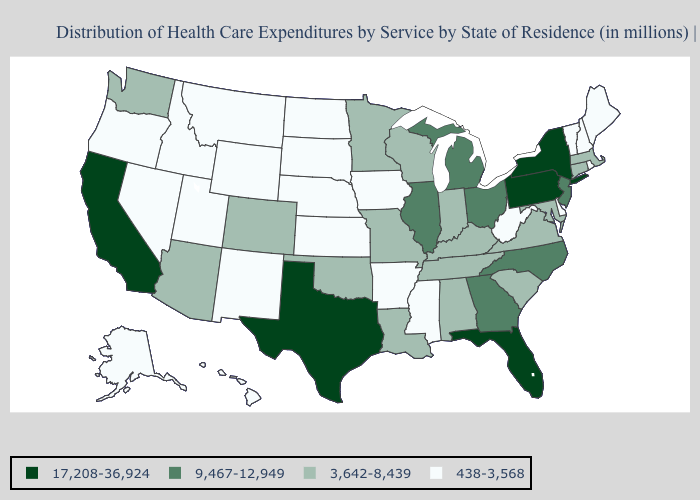Does the map have missing data?
Give a very brief answer. No. Does Louisiana have the lowest value in the USA?
Concise answer only. No. Name the states that have a value in the range 438-3,568?
Give a very brief answer. Alaska, Arkansas, Delaware, Hawaii, Idaho, Iowa, Kansas, Maine, Mississippi, Montana, Nebraska, Nevada, New Hampshire, New Mexico, North Dakota, Oregon, Rhode Island, South Dakota, Utah, Vermont, West Virginia, Wyoming. Does the map have missing data?
Answer briefly. No. What is the highest value in the USA?
Keep it brief. 17,208-36,924. What is the value of South Dakota?
Give a very brief answer. 438-3,568. Does the map have missing data?
Keep it brief. No. What is the lowest value in the South?
Give a very brief answer. 438-3,568. Name the states that have a value in the range 17,208-36,924?
Quick response, please. California, Florida, New York, Pennsylvania, Texas. Does New York have the highest value in the USA?
Short answer required. Yes. Name the states that have a value in the range 438-3,568?
Short answer required. Alaska, Arkansas, Delaware, Hawaii, Idaho, Iowa, Kansas, Maine, Mississippi, Montana, Nebraska, Nevada, New Hampshire, New Mexico, North Dakota, Oregon, Rhode Island, South Dakota, Utah, Vermont, West Virginia, Wyoming. Does the map have missing data?
Short answer required. No. Name the states that have a value in the range 438-3,568?
Keep it brief. Alaska, Arkansas, Delaware, Hawaii, Idaho, Iowa, Kansas, Maine, Mississippi, Montana, Nebraska, Nevada, New Hampshire, New Mexico, North Dakota, Oregon, Rhode Island, South Dakota, Utah, Vermont, West Virginia, Wyoming. Name the states that have a value in the range 9,467-12,949?
Write a very short answer. Georgia, Illinois, Michigan, New Jersey, North Carolina, Ohio. Name the states that have a value in the range 3,642-8,439?
Be succinct. Alabama, Arizona, Colorado, Connecticut, Indiana, Kentucky, Louisiana, Maryland, Massachusetts, Minnesota, Missouri, Oklahoma, South Carolina, Tennessee, Virginia, Washington, Wisconsin. 